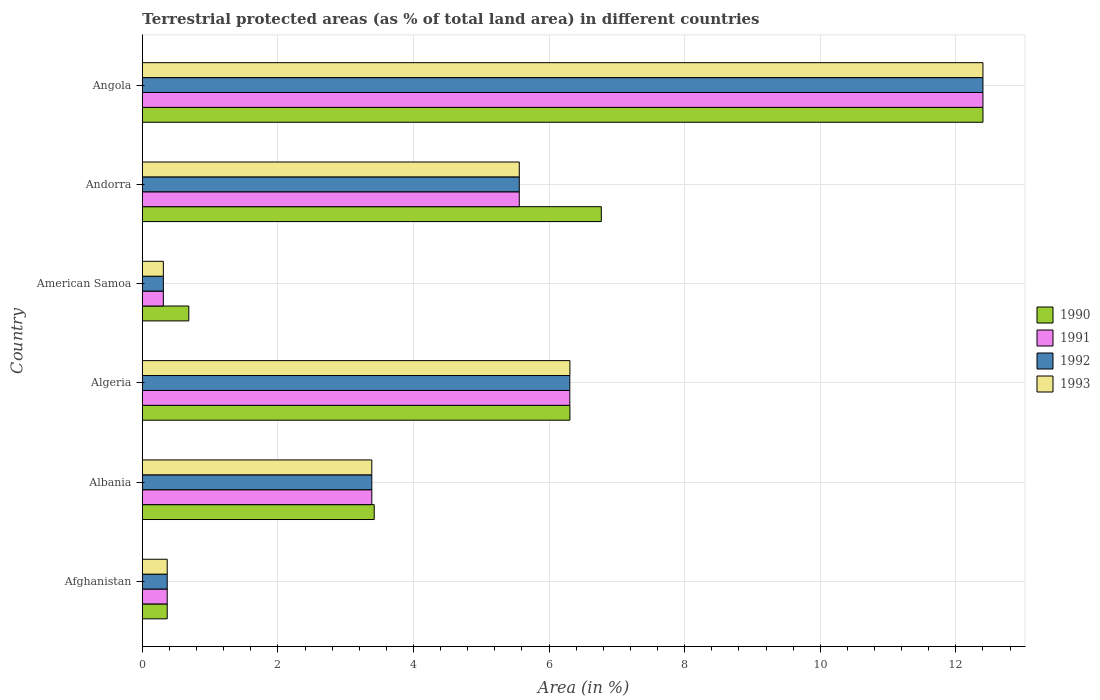How many different coloured bars are there?
Offer a terse response. 4. How many groups of bars are there?
Ensure brevity in your answer.  6. What is the label of the 2nd group of bars from the top?
Offer a terse response. Andorra. In how many cases, is the number of bars for a given country not equal to the number of legend labels?
Offer a very short reply. 0. What is the percentage of terrestrial protected land in 1991 in Andorra?
Your answer should be very brief. 5.56. Across all countries, what is the maximum percentage of terrestrial protected land in 1991?
Your answer should be compact. 12.4. Across all countries, what is the minimum percentage of terrestrial protected land in 1992?
Ensure brevity in your answer.  0.31. In which country was the percentage of terrestrial protected land in 1991 maximum?
Offer a very short reply. Angola. In which country was the percentage of terrestrial protected land in 1992 minimum?
Make the answer very short. American Samoa. What is the total percentage of terrestrial protected land in 1993 in the graph?
Ensure brevity in your answer.  28.33. What is the difference between the percentage of terrestrial protected land in 1993 in Afghanistan and that in Algeria?
Ensure brevity in your answer.  -5.94. What is the difference between the percentage of terrestrial protected land in 1992 in Andorra and the percentage of terrestrial protected land in 1991 in Angola?
Give a very brief answer. -6.84. What is the average percentage of terrestrial protected land in 1992 per country?
Offer a terse response. 4.72. What is the difference between the percentage of terrestrial protected land in 1992 and percentage of terrestrial protected land in 1991 in Algeria?
Your answer should be very brief. 0. In how many countries, is the percentage of terrestrial protected land in 1990 greater than 7.6 %?
Offer a terse response. 1. What is the ratio of the percentage of terrestrial protected land in 1992 in Afghanistan to that in Angola?
Provide a short and direct response. 0.03. Is the difference between the percentage of terrestrial protected land in 1992 in Algeria and Andorra greater than the difference between the percentage of terrestrial protected land in 1991 in Algeria and Andorra?
Provide a succinct answer. No. What is the difference between the highest and the second highest percentage of terrestrial protected land in 1993?
Offer a terse response. 6.09. What is the difference between the highest and the lowest percentage of terrestrial protected land in 1992?
Your answer should be very brief. 12.09. In how many countries, is the percentage of terrestrial protected land in 1991 greater than the average percentage of terrestrial protected land in 1991 taken over all countries?
Ensure brevity in your answer.  3. Is the sum of the percentage of terrestrial protected land in 1993 in Albania and American Samoa greater than the maximum percentage of terrestrial protected land in 1992 across all countries?
Your response must be concise. No. Is it the case that in every country, the sum of the percentage of terrestrial protected land in 1993 and percentage of terrestrial protected land in 1990 is greater than the sum of percentage of terrestrial protected land in 1991 and percentage of terrestrial protected land in 1992?
Make the answer very short. No. What does the 4th bar from the top in Andorra represents?
Make the answer very short. 1990. What does the 1st bar from the bottom in Andorra represents?
Your answer should be very brief. 1990. Is it the case that in every country, the sum of the percentage of terrestrial protected land in 1992 and percentage of terrestrial protected land in 1991 is greater than the percentage of terrestrial protected land in 1990?
Your response must be concise. No. How many bars are there?
Make the answer very short. 24. What is the difference between two consecutive major ticks on the X-axis?
Make the answer very short. 2. Are the values on the major ticks of X-axis written in scientific E-notation?
Your answer should be very brief. No. Does the graph contain any zero values?
Make the answer very short. No. Where does the legend appear in the graph?
Offer a very short reply. Center right. How are the legend labels stacked?
Provide a succinct answer. Vertical. What is the title of the graph?
Provide a succinct answer. Terrestrial protected areas (as % of total land area) in different countries. What is the label or title of the X-axis?
Offer a very short reply. Area (in %). What is the Area (in %) in 1990 in Afghanistan?
Your response must be concise. 0.37. What is the Area (in %) of 1991 in Afghanistan?
Give a very brief answer. 0.37. What is the Area (in %) in 1992 in Afghanistan?
Make the answer very short. 0.37. What is the Area (in %) in 1993 in Afghanistan?
Provide a short and direct response. 0.37. What is the Area (in %) in 1990 in Albania?
Offer a terse response. 3.42. What is the Area (in %) of 1991 in Albania?
Ensure brevity in your answer.  3.38. What is the Area (in %) in 1992 in Albania?
Your response must be concise. 3.38. What is the Area (in %) in 1993 in Albania?
Give a very brief answer. 3.38. What is the Area (in %) in 1990 in Algeria?
Your answer should be compact. 6.31. What is the Area (in %) of 1991 in Algeria?
Your response must be concise. 6.31. What is the Area (in %) of 1992 in Algeria?
Your answer should be compact. 6.31. What is the Area (in %) of 1993 in Algeria?
Provide a succinct answer. 6.31. What is the Area (in %) in 1990 in American Samoa?
Ensure brevity in your answer.  0.69. What is the Area (in %) in 1991 in American Samoa?
Your response must be concise. 0.31. What is the Area (in %) of 1992 in American Samoa?
Provide a short and direct response. 0.31. What is the Area (in %) in 1993 in American Samoa?
Provide a succinct answer. 0.31. What is the Area (in %) of 1990 in Andorra?
Your response must be concise. 6.77. What is the Area (in %) in 1991 in Andorra?
Give a very brief answer. 5.56. What is the Area (in %) of 1992 in Andorra?
Your answer should be compact. 5.56. What is the Area (in %) in 1993 in Andorra?
Offer a very short reply. 5.56. What is the Area (in %) in 1990 in Angola?
Provide a succinct answer. 12.4. What is the Area (in %) of 1991 in Angola?
Your answer should be very brief. 12.4. What is the Area (in %) of 1992 in Angola?
Your response must be concise. 12.4. What is the Area (in %) in 1993 in Angola?
Keep it short and to the point. 12.4. Across all countries, what is the maximum Area (in %) in 1990?
Your answer should be very brief. 12.4. Across all countries, what is the maximum Area (in %) in 1991?
Offer a very short reply. 12.4. Across all countries, what is the maximum Area (in %) of 1992?
Provide a succinct answer. 12.4. Across all countries, what is the maximum Area (in %) in 1993?
Keep it short and to the point. 12.4. Across all countries, what is the minimum Area (in %) of 1990?
Give a very brief answer. 0.37. Across all countries, what is the minimum Area (in %) in 1991?
Give a very brief answer. 0.31. Across all countries, what is the minimum Area (in %) in 1992?
Your answer should be very brief. 0.31. Across all countries, what is the minimum Area (in %) in 1993?
Make the answer very short. 0.31. What is the total Area (in %) of 1990 in the graph?
Offer a very short reply. 29.95. What is the total Area (in %) in 1991 in the graph?
Offer a very short reply. 28.33. What is the total Area (in %) in 1992 in the graph?
Your response must be concise. 28.33. What is the total Area (in %) of 1993 in the graph?
Keep it short and to the point. 28.33. What is the difference between the Area (in %) in 1990 in Afghanistan and that in Albania?
Your response must be concise. -3.05. What is the difference between the Area (in %) in 1991 in Afghanistan and that in Albania?
Your answer should be very brief. -3.02. What is the difference between the Area (in %) of 1992 in Afghanistan and that in Albania?
Give a very brief answer. -3.02. What is the difference between the Area (in %) in 1993 in Afghanistan and that in Albania?
Offer a terse response. -3.02. What is the difference between the Area (in %) in 1990 in Afghanistan and that in Algeria?
Give a very brief answer. -5.94. What is the difference between the Area (in %) in 1991 in Afghanistan and that in Algeria?
Keep it short and to the point. -5.94. What is the difference between the Area (in %) of 1992 in Afghanistan and that in Algeria?
Offer a terse response. -5.94. What is the difference between the Area (in %) in 1993 in Afghanistan and that in Algeria?
Your response must be concise. -5.94. What is the difference between the Area (in %) in 1990 in Afghanistan and that in American Samoa?
Give a very brief answer. -0.32. What is the difference between the Area (in %) of 1991 in Afghanistan and that in American Samoa?
Your answer should be compact. 0.06. What is the difference between the Area (in %) in 1992 in Afghanistan and that in American Samoa?
Your answer should be compact. 0.06. What is the difference between the Area (in %) in 1993 in Afghanistan and that in American Samoa?
Provide a short and direct response. 0.06. What is the difference between the Area (in %) in 1990 in Afghanistan and that in Andorra?
Your response must be concise. -6.4. What is the difference between the Area (in %) in 1991 in Afghanistan and that in Andorra?
Keep it short and to the point. -5.19. What is the difference between the Area (in %) in 1992 in Afghanistan and that in Andorra?
Offer a very short reply. -5.19. What is the difference between the Area (in %) in 1993 in Afghanistan and that in Andorra?
Your answer should be compact. -5.19. What is the difference between the Area (in %) in 1990 in Afghanistan and that in Angola?
Your response must be concise. -12.03. What is the difference between the Area (in %) in 1991 in Afghanistan and that in Angola?
Your answer should be compact. -12.03. What is the difference between the Area (in %) in 1992 in Afghanistan and that in Angola?
Make the answer very short. -12.03. What is the difference between the Area (in %) in 1993 in Afghanistan and that in Angola?
Provide a succinct answer. -12.03. What is the difference between the Area (in %) of 1990 in Albania and that in Algeria?
Your answer should be very brief. -2.89. What is the difference between the Area (in %) of 1991 in Albania and that in Algeria?
Your response must be concise. -2.92. What is the difference between the Area (in %) in 1992 in Albania and that in Algeria?
Your response must be concise. -2.92. What is the difference between the Area (in %) of 1993 in Albania and that in Algeria?
Make the answer very short. -2.92. What is the difference between the Area (in %) in 1990 in Albania and that in American Samoa?
Offer a very short reply. 2.73. What is the difference between the Area (in %) of 1991 in Albania and that in American Samoa?
Keep it short and to the point. 3.07. What is the difference between the Area (in %) in 1992 in Albania and that in American Samoa?
Your response must be concise. 3.07. What is the difference between the Area (in %) of 1993 in Albania and that in American Samoa?
Your answer should be very brief. 3.07. What is the difference between the Area (in %) in 1990 in Albania and that in Andorra?
Make the answer very short. -3.35. What is the difference between the Area (in %) in 1991 in Albania and that in Andorra?
Offer a terse response. -2.18. What is the difference between the Area (in %) of 1992 in Albania and that in Andorra?
Make the answer very short. -2.18. What is the difference between the Area (in %) in 1993 in Albania and that in Andorra?
Give a very brief answer. -2.18. What is the difference between the Area (in %) of 1990 in Albania and that in Angola?
Make the answer very short. -8.98. What is the difference between the Area (in %) in 1991 in Albania and that in Angola?
Your response must be concise. -9.01. What is the difference between the Area (in %) in 1992 in Albania and that in Angola?
Ensure brevity in your answer.  -9.01. What is the difference between the Area (in %) in 1993 in Albania and that in Angola?
Provide a succinct answer. -9.01. What is the difference between the Area (in %) in 1990 in Algeria and that in American Samoa?
Keep it short and to the point. 5.62. What is the difference between the Area (in %) of 1991 in Algeria and that in American Samoa?
Make the answer very short. 6. What is the difference between the Area (in %) in 1992 in Algeria and that in American Samoa?
Ensure brevity in your answer.  6. What is the difference between the Area (in %) of 1993 in Algeria and that in American Samoa?
Offer a terse response. 6. What is the difference between the Area (in %) of 1990 in Algeria and that in Andorra?
Your response must be concise. -0.46. What is the difference between the Area (in %) of 1991 in Algeria and that in Andorra?
Give a very brief answer. 0.75. What is the difference between the Area (in %) of 1992 in Algeria and that in Andorra?
Your answer should be very brief. 0.75. What is the difference between the Area (in %) in 1993 in Algeria and that in Andorra?
Give a very brief answer. 0.75. What is the difference between the Area (in %) of 1990 in Algeria and that in Angola?
Give a very brief answer. -6.09. What is the difference between the Area (in %) of 1991 in Algeria and that in Angola?
Offer a terse response. -6.09. What is the difference between the Area (in %) of 1992 in Algeria and that in Angola?
Ensure brevity in your answer.  -6.09. What is the difference between the Area (in %) of 1993 in Algeria and that in Angola?
Your answer should be very brief. -6.09. What is the difference between the Area (in %) in 1990 in American Samoa and that in Andorra?
Your answer should be very brief. -6.08. What is the difference between the Area (in %) in 1991 in American Samoa and that in Andorra?
Provide a succinct answer. -5.25. What is the difference between the Area (in %) in 1992 in American Samoa and that in Andorra?
Keep it short and to the point. -5.25. What is the difference between the Area (in %) in 1993 in American Samoa and that in Andorra?
Provide a short and direct response. -5.25. What is the difference between the Area (in %) in 1990 in American Samoa and that in Angola?
Keep it short and to the point. -11.71. What is the difference between the Area (in %) in 1991 in American Samoa and that in Angola?
Make the answer very short. -12.09. What is the difference between the Area (in %) in 1992 in American Samoa and that in Angola?
Your answer should be very brief. -12.09. What is the difference between the Area (in %) in 1993 in American Samoa and that in Angola?
Offer a terse response. -12.09. What is the difference between the Area (in %) in 1990 in Andorra and that in Angola?
Give a very brief answer. -5.63. What is the difference between the Area (in %) of 1991 in Andorra and that in Angola?
Your answer should be very brief. -6.84. What is the difference between the Area (in %) of 1992 in Andorra and that in Angola?
Your answer should be compact. -6.84. What is the difference between the Area (in %) in 1993 in Andorra and that in Angola?
Offer a terse response. -6.84. What is the difference between the Area (in %) of 1990 in Afghanistan and the Area (in %) of 1991 in Albania?
Provide a short and direct response. -3.02. What is the difference between the Area (in %) of 1990 in Afghanistan and the Area (in %) of 1992 in Albania?
Your answer should be very brief. -3.02. What is the difference between the Area (in %) in 1990 in Afghanistan and the Area (in %) in 1993 in Albania?
Make the answer very short. -3.02. What is the difference between the Area (in %) of 1991 in Afghanistan and the Area (in %) of 1992 in Albania?
Provide a succinct answer. -3.02. What is the difference between the Area (in %) of 1991 in Afghanistan and the Area (in %) of 1993 in Albania?
Keep it short and to the point. -3.02. What is the difference between the Area (in %) in 1992 in Afghanistan and the Area (in %) in 1993 in Albania?
Provide a succinct answer. -3.02. What is the difference between the Area (in %) of 1990 in Afghanistan and the Area (in %) of 1991 in Algeria?
Provide a succinct answer. -5.94. What is the difference between the Area (in %) of 1990 in Afghanistan and the Area (in %) of 1992 in Algeria?
Ensure brevity in your answer.  -5.94. What is the difference between the Area (in %) in 1990 in Afghanistan and the Area (in %) in 1993 in Algeria?
Your answer should be compact. -5.94. What is the difference between the Area (in %) in 1991 in Afghanistan and the Area (in %) in 1992 in Algeria?
Offer a terse response. -5.94. What is the difference between the Area (in %) in 1991 in Afghanistan and the Area (in %) in 1993 in Algeria?
Your answer should be compact. -5.94. What is the difference between the Area (in %) of 1992 in Afghanistan and the Area (in %) of 1993 in Algeria?
Your response must be concise. -5.94. What is the difference between the Area (in %) in 1990 in Afghanistan and the Area (in %) in 1991 in American Samoa?
Make the answer very short. 0.06. What is the difference between the Area (in %) of 1990 in Afghanistan and the Area (in %) of 1992 in American Samoa?
Keep it short and to the point. 0.06. What is the difference between the Area (in %) in 1990 in Afghanistan and the Area (in %) in 1993 in American Samoa?
Offer a very short reply. 0.06. What is the difference between the Area (in %) of 1991 in Afghanistan and the Area (in %) of 1992 in American Samoa?
Your answer should be very brief. 0.06. What is the difference between the Area (in %) of 1991 in Afghanistan and the Area (in %) of 1993 in American Samoa?
Give a very brief answer. 0.06. What is the difference between the Area (in %) of 1992 in Afghanistan and the Area (in %) of 1993 in American Samoa?
Make the answer very short. 0.06. What is the difference between the Area (in %) in 1990 in Afghanistan and the Area (in %) in 1991 in Andorra?
Provide a short and direct response. -5.19. What is the difference between the Area (in %) in 1990 in Afghanistan and the Area (in %) in 1992 in Andorra?
Your answer should be compact. -5.19. What is the difference between the Area (in %) of 1990 in Afghanistan and the Area (in %) of 1993 in Andorra?
Your answer should be very brief. -5.19. What is the difference between the Area (in %) of 1991 in Afghanistan and the Area (in %) of 1992 in Andorra?
Ensure brevity in your answer.  -5.19. What is the difference between the Area (in %) of 1991 in Afghanistan and the Area (in %) of 1993 in Andorra?
Keep it short and to the point. -5.19. What is the difference between the Area (in %) of 1992 in Afghanistan and the Area (in %) of 1993 in Andorra?
Keep it short and to the point. -5.19. What is the difference between the Area (in %) of 1990 in Afghanistan and the Area (in %) of 1991 in Angola?
Keep it short and to the point. -12.03. What is the difference between the Area (in %) in 1990 in Afghanistan and the Area (in %) in 1992 in Angola?
Your answer should be compact. -12.03. What is the difference between the Area (in %) of 1990 in Afghanistan and the Area (in %) of 1993 in Angola?
Ensure brevity in your answer.  -12.03. What is the difference between the Area (in %) in 1991 in Afghanistan and the Area (in %) in 1992 in Angola?
Offer a terse response. -12.03. What is the difference between the Area (in %) in 1991 in Afghanistan and the Area (in %) in 1993 in Angola?
Keep it short and to the point. -12.03. What is the difference between the Area (in %) of 1992 in Afghanistan and the Area (in %) of 1993 in Angola?
Offer a terse response. -12.03. What is the difference between the Area (in %) in 1990 in Albania and the Area (in %) in 1991 in Algeria?
Provide a short and direct response. -2.89. What is the difference between the Area (in %) of 1990 in Albania and the Area (in %) of 1992 in Algeria?
Ensure brevity in your answer.  -2.89. What is the difference between the Area (in %) of 1990 in Albania and the Area (in %) of 1993 in Algeria?
Give a very brief answer. -2.89. What is the difference between the Area (in %) in 1991 in Albania and the Area (in %) in 1992 in Algeria?
Provide a short and direct response. -2.92. What is the difference between the Area (in %) of 1991 in Albania and the Area (in %) of 1993 in Algeria?
Your answer should be very brief. -2.92. What is the difference between the Area (in %) in 1992 in Albania and the Area (in %) in 1993 in Algeria?
Offer a very short reply. -2.92. What is the difference between the Area (in %) of 1990 in Albania and the Area (in %) of 1991 in American Samoa?
Make the answer very short. 3.11. What is the difference between the Area (in %) of 1990 in Albania and the Area (in %) of 1992 in American Samoa?
Ensure brevity in your answer.  3.11. What is the difference between the Area (in %) of 1990 in Albania and the Area (in %) of 1993 in American Samoa?
Make the answer very short. 3.11. What is the difference between the Area (in %) in 1991 in Albania and the Area (in %) in 1992 in American Samoa?
Your answer should be compact. 3.07. What is the difference between the Area (in %) in 1991 in Albania and the Area (in %) in 1993 in American Samoa?
Your response must be concise. 3.07. What is the difference between the Area (in %) in 1992 in Albania and the Area (in %) in 1993 in American Samoa?
Keep it short and to the point. 3.07. What is the difference between the Area (in %) in 1990 in Albania and the Area (in %) in 1991 in Andorra?
Offer a terse response. -2.14. What is the difference between the Area (in %) in 1990 in Albania and the Area (in %) in 1992 in Andorra?
Your answer should be very brief. -2.14. What is the difference between the Area (in %) in 1990 in Albania and the Area (in %) in 1993 in Andorra?
Give a very brief answer. -2.14. What is the difference between the Area (in %) in 1991 in Albania and the Area (in %) in 1992 in Andorra?
Make the answer very short. -2.18. What is the difference between the Area (in %) of 1991 in Albania and the Area (in %) of 1993 in Andorra?
Your response must be concise. -2.18. What is the difference between the Area (in %) of 1992 in Albania and the Area (in %) of 1993 in Andorra?
Your answer should be compact. -2.18. What is the difference between the Area (in %) of 1990 in Albania and the Area (in %) of 1991 in Angola?
Make the answer very short. -8.98. What is the difference between the Area (in %) in 1990 in Albania and the Area (in %) in 1992 in Angola?
Make the answer very short. -8.98. What is the difference between the Area (in %) in 1990 in Albania and the Area (in %) in 1993 in Angola?
Offer a very short reply. -8.98. What is the difference between the Area (in %) in 1991 in Albania and the Area (in %) in 1992 in Angola?
Provide a short and direct response. -9.01. What is the difference between the Area (in %) in 1991 in Albania and the Area (in %) in 1993 in Angola?
Ensure brevity in your answer.  -9.01. What is the difference between the Area (in %) in 1992 in Albania and the Area (in %) in 1993 in Angola?
Your answer should be compact. -9.01. What is the difference between the Area (in %) of 1990 in Algeria and the Area (in %) of 1991 in American Samoa?
Provide a short and direct response. 6. What is the difference between the Area (in %) of 1990 in Algeria and the Area (in %) of 1992 in American Samoa?
Offer a very short reply. 6. What is the difference between the Area (in %) of 1990 in Algeria and the Area (in %) of 1993 in American Samoa?
Provide a short and direct response. 6. What is the difference between the Area (in %) of 1991 in Algeria and the Area (in %) of 1992 in American Samoa?
Your answer should be compact. 6. What is the difference between the Area (in %) in 1991 in Algeria and the Area (in %) in 1993 in American Samoa?
Your answer should be compact. 6. What is the difference between the Area (in %) in 1992 in Algeria and the Area (in %) in 1993 in American Samoa?
Give a very brief answer. 6. What is the difference between the Area (in %) in 1990 in Algeria and the Area (in %) in 1991 in Andorra?
Your answer should be compact. 0.75. What is the difference between the Area (in %) in 1990 in Algeria and the Area (in %) in 1992 in Andorra?
Offer a very short reply. 0.75. What is the difference between the Area (in %) in 1990 in Algeria and the Area (in %) in 1993 in Andorra?
Your answer should be compact. 0.75. What is the difference between the Area (in %) in 1991 in Algeria and the Area (in %) in 1992 in Andorra?
Your response must be concise. 0.75. What is the difference between the Area (in %) of 1991 in Algeria and the Area (in %) of 1993 in Andorra?
Offer a terse response. 0.75. What is the difference between the Area (in %) of 1992 in Algeria and the Area (in %) of 1993 in Andorra?
Provide a short and direct response. 0.75. What is the difference between the Area (in %) in 1990 in Algeria and the Area (in %) in 1991 in Angola?
Your response must be concise. -6.09. What is the difference between the Area (in %) of 1990 in Algeria and the Area (in %) of 1992 in Angola?
Your response must be concise. -6.09. What is the difference between the Area (in %) in 1990 in Algeria and the Area (in %) in 1993 in Angola?
Your answer should be compact. -6.09. What is the difference between the Area (in %) in 1991 in Algeria and the Area (in %) in 1992 in Angola?
Provide a short and direct response. -6.09. What is the difference between the Area (in %) in 1991 in Algeria and the Area (in %) in 1993 in Angola?
Provide a short and direct response. -6.09. What is the difference between the Area (in %) in 1992 in Algeria and the Area (in %) in 1993 in Angola?
Your answer should be compact. -6.09. What is the difference between the Area (in %) of 1990 in American Samoa and the Area (in %) of 1991 in Andorra?
Provide a short and direct response. -4.87. What is the difference between the Area (in %) of 1990 in American Samoa and the Area (in %) of 1992 in Andorra?
Your response must be concise. -4.87. What is the difference between the Area (in %) in 1990 in American Samoa and the Area (in %) in 1993 in Andorra?
Your answer should be compact. -4.87. What is the difference between the Area (in %) of 1991 in American Samoa and the Area (in %) of 1992 in Andorra?
Provide a short and direct response. -5.25. What is the difference between the Area (in %) of 1991 in American Samoa and the Area (in %) of 1993 in Andorra?
Ensure brevity in your answer.  -5.25. What is the difference between the Area (in %) in 1992 in American Samoa and the Area (in %) in 1993 in Andorra?
Keep it short and to the point. -5.25. What is the difference between the Area (in %) of 1990 in American Samoa and the Area (in %) of 1991 in Angola?
Your answer should be compact. -11.71. What is the difference between the Area (in %) in 1990 in American Samoa and the Area (in %) in 1992 in Angola?
Your response must be concise. -11.71. What is the difference between the Area (in %) in 1990 in American Samoa and the Area (in %) in 1993 in Angola?
Offer a terse response. -11.71. What is the difference between the Area (in %) of 1991 in American Samoa and the Area (in %) of 1992 in Angola?
Offer a terse response. -12.09. What is the difference between the Area (in %) of 1991 in American Samoa and the Area (in %) of 1993 in Angola?
Offer a very short reply. -12.09. What is the difference between the Area (in %) in 1992 in American Samoa and the Area (in %) in 1993 in Angola?
Keep it short and to the point. -12.09. What is the difference between the Area (in %) of 1990 in Andorra and the Area (in %) of 1991 in Angola?
Your answer should be compact. -5.63. What is the difference between the Area (in %) of 1990 in Andorra and the Area (in %) of 1992 in Angola?
Ensure brevity in your answer.  -5.63. What is the difference between the Area (in %) of 1990 in Andorra and the Area (in %) of 1993 in Angola?
Your answer should be very brief. -5.63. What is the difference between the Area (in %) in 1991 in Andorra and the Area (in %) in 1992 in Angola?
Give a very brief answer. -6.84. What is the difference between the Area (in %) of 1991 in Andorra and the Area (in %) of 1993 in Angola?
Your answer should be compact. -6.84. What is the difference between the Area (in %) of 1992 in Andorra and the Area (in %) of 1993 in Angola?
Offer a terse response. -6.84. What is the average Area (in %) of 1990 per country?
Keep it short and to the point. 4.99. What is the average Area (in %) in 1991 per country?
Keep it short and to the point. 4.72. What is the average Area (in %) of 1992 per country?
Provide a succinct answer. 4.72. What is the average Area (in %) of 1993 per country?
Offer a terse response. 4.72. What is the difference between the Area (in %) in 1990 and Area (in %) in 1991 in Albania?
Give a very brief answer. 0.04. What is the difference between the Area (in %) in 1990 and Area (in %) in 1992 in Albania?
Your response must be concise. 0.04. What is the difference between the Area (in %) in 1990 and Area (in %) in 1993 in Albania?
Ensure brevity in your answer.  0.04. What is the difference between the Area (in %) of 1992 and Area (in %) of 1993 in Albania?
Ensure brevity in your answer.  0. What is the difference between the Area (in %) in 1990 and Area (in %) in 1991 in Algeria?
Ensure brevity in your answer.  0. What is the difference between the Area (in %) of 1990 and Area (in %) of 1992 in Algeria?
Your answer should be very brief. 0. What is the difference between the Area (in %) in 1991 and Area (in %) in 1992 in Algeria?
Your response must be concise. 0. What is the difference between the Area (in %) in 1991 and Area (in %) in 1993 in Algeria?
Offer a very short reply. -0. What is the difference between the Area (in %) in 1992 and Area (in %) in 1993 in Algeria?
Ensure brevity in your answer.  -0. What is the difference between the Area (in %) of 1990 and Area (in %) of 1991 in American Samoa?
Provide a succinct answer. 0.38. What is the difference between the Area (in %) of 1990 and Area (in %) of 1992 in American Samoa?
Keep it short and to the point. 0.38. What is the difference between the Area (in %) in 1990 and Area (in %) in 1993 in American Samoa?
Make the answer very short. 0.38. What is the difference between the Area (in %) of 1991 and Area (in %) of 1992 in American Samoa?
Your response must be concise. 0. What is the difference between the Area (in %) in 1990 and Area (in %) in 1991 in Andorra?
Give a very brief answer. 1.21. What is the difference between the Area (in %) of 1990 and Area (in %) of 1992 in Andorra?
Make the answer very short. 1.21. What is the difference between the Area (in %) of 1990 and Area (in %) of 1993 in Andorra?
Your answer should be compact. 1.21. What is the difference between the Area (in %) in 1990 and Area (in %) in 1991 in Angola?
Your response must be concise. 0. What is the difference between the Area (in %) of 1990 and Area (in %) of 1992 in Angola?
Your answer should be compact. 0. What is the difference between the Area (in %) of 1990 and Area (in %) of 1993 in Angola?
Provide a succinct answer. 0. What is the difference between the Area (in %) in 1991 and Area (in %) in 1992 in Angola?
Ensure brevity in your answer.  0. What is the ratio of the Area (in %) in 1990 in Afghanistan to that in Albania?
Give a very brief answer. 0.11. What is the ratio of the Area (in %) of 1991 in Afghanistan to that in Albania?
Provide a succinct answer. 0.11. What is the ratio of the Area (in %) in 1992 in Afghanistan to that in Albania?
Offer a terse response. 0.11. What is the ratio of the Area (in %) of 1993 in Afghanistan to that in Albania?
Make the answer very short. 0.11. What is the ratio of the Area (in %) of 1990 in Afghanistan to that in Algeria?
Provide a short and direct response. 0.06. What is the ratio of the Area (in %) in 1991 in Afghanistan to that in Algeria?
Your answer should be very brief. 0.06. What is the ratio of the Area (in %) of 1992 in Afghanistan to that in Algeria?
Give a very brief answer. 0.06. What is the ratio of the Area (in %) of 1993 in Afghanistan to that in Algeria?
Your answer should be compact. 0.06. What is the ratio of the Area (in %) of 1990 in Afghanistan to that in American Samoa?
Give a very brief answer. 0.54. What is the ratio of the Area (in %) in 1991 in Afghanistan to that in American Samoa?
Ensure brevity in your answer.  1.18. What is the ratio of the Area (in %) of 1992 in Afghanistan to that in American Samoa?
Your answer should be very brief. 1.18. What is the ratio of the Area (in %) in 1993 in Afghanistan to that in American Samoa?
Your answer should be compact. 1.18. What is the ratio of the Area (in %) in 1990 in Afghanistan to that in Andorra?
Your response must be concise. 0.05. What is the ratio of the Area (in %) in 1991 in Afghanistan to that in Andorra?
Provide a succinct answer. 0.07. What is the ratio of the Area (in %) in 1992 in Afghanistan to that in Andorra?
Your answer should be very brief. 0.07. What is the ratio of the Area (in %) of 1993 in Afghanistan to that in Andorra?
Your answer should be very brief. 0.07. What is the ratio of the Area (in %) of 1990 in Afghanistan to that in Angola?
Make the answer very short. 0.03. What is the ratio of the Area (in %) of 1991 in Afghanistan to that in Angola?
Provide a short and direct response. 0.03. What is the ratio of the Area (in %) of 1992 in Afghanistan to that in Angola?
Keep it short and to the point. 0.03. What is the ratio of the Area (in %) of 1993 in Afghanistan to that in Angola?
Provide a short and direct response. 0.03. What is the ratio of the Area (in %) in 1990 in Albania to that in Algeria?
Offer a terse response. 0.54. What is the ratio of the Area (in %) of 1991 in Albania to that in Algeria?
Ensure brevity in your answer.  0.54. What is the ratio of the Area (in %) of 1992 in Albania to that in Algeria?
Offer a terse response. 0.54. What is the ratio of the Area (in %) in 1993 in Albania to that in Algeria?
Give a very brief answer. 0.54. What is the ratio of the Area (in %) of 1990 in Albania to that in American Samoa?
Make the answer very short. 4.99. What is the ratio of the Area (in %) in 1991 in Albania to that in American Samoa?
Your answer should be compact. 10.91. What is the ratio of the Area (in %) of 1992 in Albania to that in American Samoa?
Your answer should be very brief. 10.91. What is the ratio of the Area (in %) in 1993 in Albania to that in American Samoa?
Your answer should be very brief. 10.91. What is the ratio of the Area (in %) in 1990 in Albania to that in Andorra?
Your answer should be compact. 0.51. What is the ratio of the Area (in %) in 1991 in Albania to that in Andorra?
Your response must be concise. 0.61. What is the ratio of the Area (in %) of 1992 in Albania to that in Andorra?
Your answer should be very brief. 0.61. What is the ratio of the Area (in %) of 1993 in Albania to that in Andorra?
Give a very brief answer. 0.61. What is the ratio of the Area (in %) of 1990 in Albania to that in Angola?
Offer a very short reply. 0.28. What is the ratio of the Area (in %) in 1991 in Albania to that in Angola?
Your response must be concise. 0.27. What is the ratio of the Area (in %) of 1992 in Albania to that in Angola?
Make the answer very short. 0.27. What is the ratio of the Area (in %) in 1993 in Albania to that in Angola?
Your answer should be compact. 0.27. What is the ratio of the Area (in %) in 1990 in Algeria to that in American Samoa?
Keep it short and to the point. 9.2. What is the ratio of the Area (in %) of 1991 in Algeria to that in American Samoa?
Ensure brevity in your answer.  20.33. What is the ratio of the Area (in %) in 1992 in Algeria to that in American Samoa?
Make the answer very short. 20.33. What is the ratio of the Area (in %) in 1993 in Algeria to that in American Samoa?
Make the answer very short. 20.34. What is the ratio of the Area (in %) in 1990 in Algeria to that in Andorra?
Your response must be concise. 0.93. What is the ratio of the Area (in %) of 1991 in Algeria to that in Andorra?
Offer a terse response. 1.13. What is the ratio of the Area (in %) in 1992 in Algeria to that in Andorra?
Make the answer very short. 1.13. What is the ratio of the Area (in %) in 1993 in Algeria to that in Andorra?
Your answer should be compact. 1.13. What is the ratio of the Area (in %) of 1990 in Algeria to that in Angola?
Keep it short and to the point. 0.51. What is the ratio of the Area (in %) of 1991 in Algeria to that in Angola?
Provide a succinct answer. 0.51. What is the ratio of the Area (in %) of 1992 in Algeria to that in Angola?
Ensure brevity in your answer.  0.51. What is the ratio of the Area (in %) in 1993 in Algeria to that in Angola?
Offer a terse response. 0.51. What is the ratio of the Area (in %) of 1990 in American Samoa to that in Andorra?
Your answer should be very brief. 0.1. What is the ratio of the Area (in %) in 1991 in American Samoa to that in Andorra?
Offer a terse response. 0.06. What is the ratio of the Area (in %) of 1992 in American Samoa to that in Andorra?
Offer a terse response. 0.06. What is the ratio of the Area (in %) of 1993 in American Samoa to that in Andorra?
Your answer should be very brief. 0.06. What is the ratio of the Area (in %) of 1990 in American Samoa to that in Angola?
Make the answer very short. 0.06. What is the ratio of the Area (in %) in 1991 in American Samoa to that in Angola?
Give a very brief answer. 0.03. What is the ratio of the Area (in %) of 1992 in American Samoa to that in Angola?
Ensure brevity in your answer.  0.03. What is the ratio of the Area (in %) in 1993 in American Samoa to that in Angola?
Your response must be concise. 0.03. What is the ratio of the Area (in %) of 1990 in Andorra to that in Angola?
Offer a very short reply. 0.55. What is the ratio of the Area (in %) in 1991 in Andorra to that in Angola?
Keep it short and to the point. 0.45. What is the ratio of the Area (in %) in 1992 in Andorra to that in Angola?
Ensure brevity in your answer.  0.45. What is the ratio of the Area (in %) in 1993 in Andorra to that in Angola?
Offer a terse response. 0.45. What is the difference between the highest and the second highest Area (in %) of 1990?
Provide a succinct answer. 5.63. What is the difference between the highest and the second highest Area (in %) of 1991?
Your response must be concise. 6.09. What is the difference between the highest and the second highest Area (in %) of 1992?
Give a very brief answer. 6.09. What is the difference between the highest and the second highest Area (in %) in 1993?
Your response must be concise. 6.09. What is the difference between the highest and the lowest Area (in %) of 1990?
Keep it short and to the point. 12.03. What is the difference between the highest and the lowest Area (in %) in 1991?
Keep it short and to the point. 12.09. What is the difference between the highest and the lowest Area (in %) of 1992?
Ensure brevity in your answer.  12.09. What is the difference between the highest and the lowest Area (in %) in 1993?
Your answer should be compact. 12.09. 